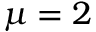Convert formula to latex. <formula><loc_0><loc_0><loc_500><loc_500>\mu = 2</formula> 